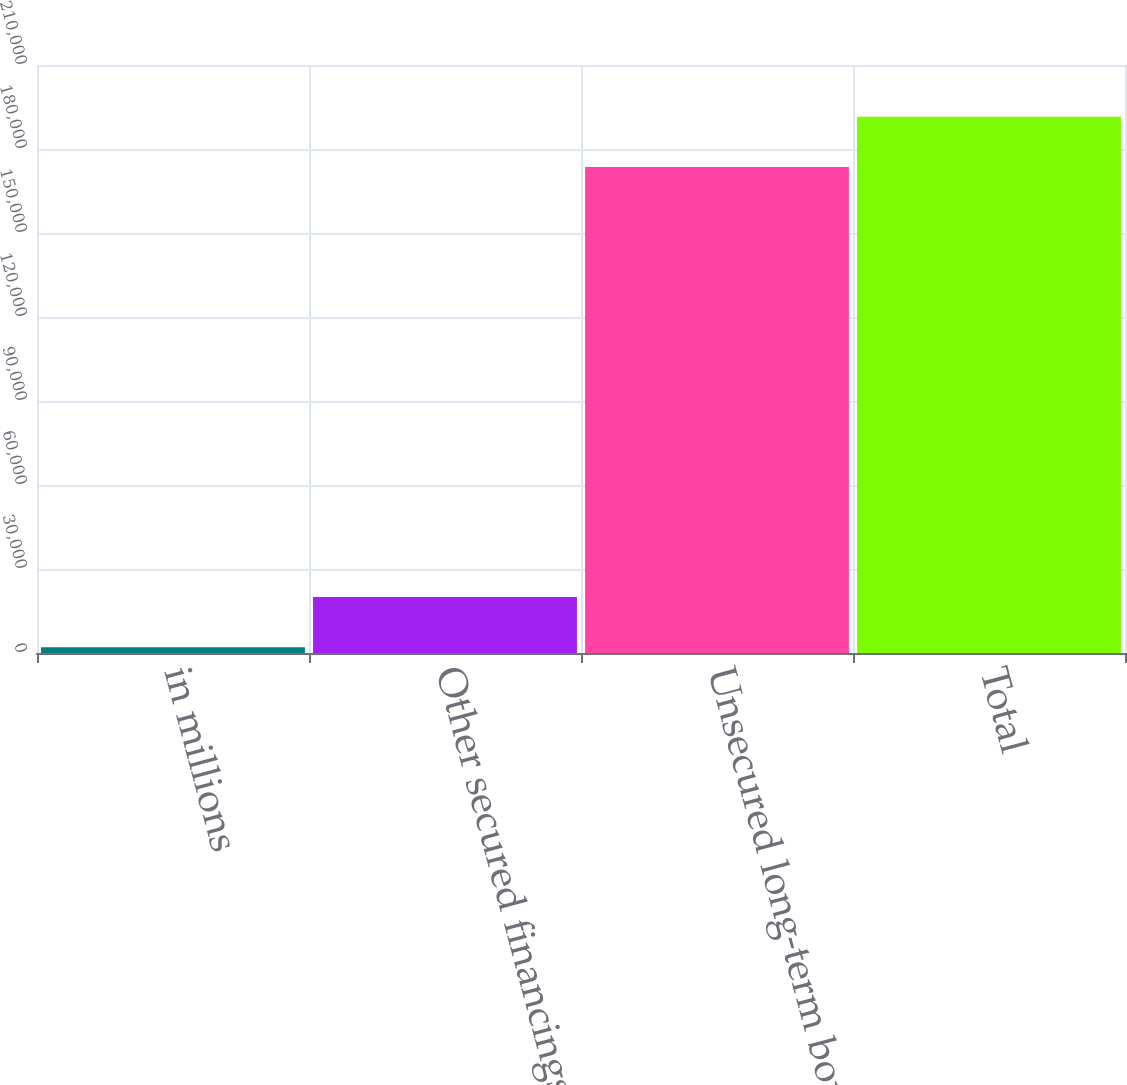<chart> <loc_0><loc_0><loc_500><loc_500><bar_chart><fcel>in millions<fcel>Other secured financings<fcel>Unsecured long-term borrowings<fcel>Total<nl><fcel>2011<fcel>19982.3<fcel>173545<fcel>191516<nl></chart> 